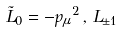Convert formula to latex. <formula><loc_0><loc_0><loc_500><loc_500>\tilde { L } _ { 0 } = - { p _ { \mu } } ^ { 2 } \, , \, L _ { \pm 1 }</formula> 